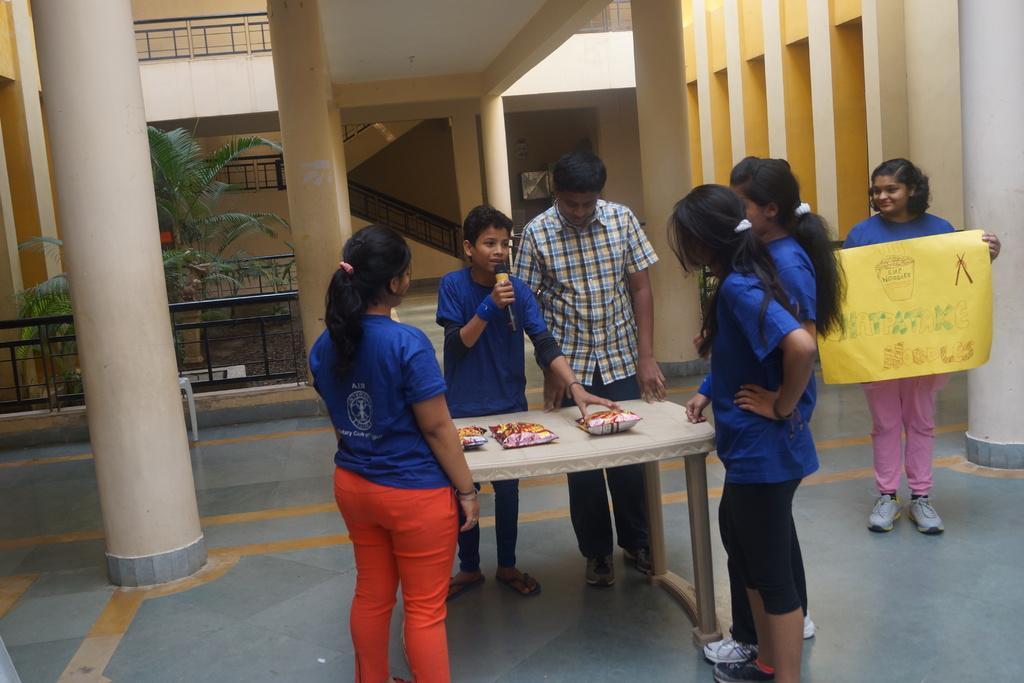Could you give a brief overview of what you see in this image? A girl standing on the right is holding a banner. There are six students standing around a table. In the middle a boy is holding a mic. On the table there are some packets. Also there are many pillars. In the background there is a railing, trees and a staircase. 